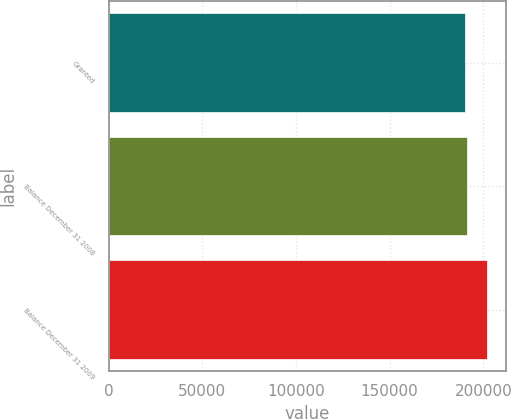Convert chart. <chart><loc_0><loc_0><loc_500><loc_500><bar_chart><fcel>Granted<fcel>Balance December 31 2008<fcel>Balance December 31 2009<nl><fcel>190000<fcel>191200<fcel>202000<nl></chart> 